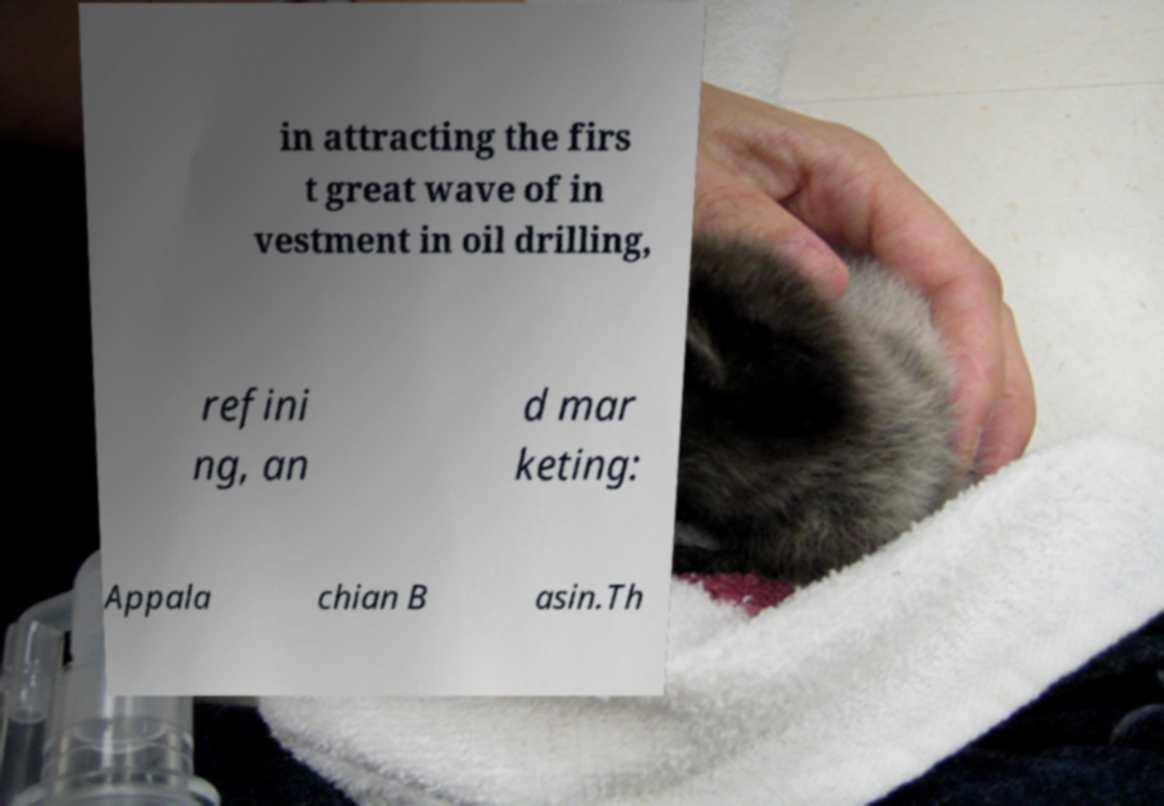I need the written content from this picture converted into text. Can you do that? in attracting the firs t great wave of in vestment in oil drilling, refini ng, an d mar keting: Appala chian B asin.Th 